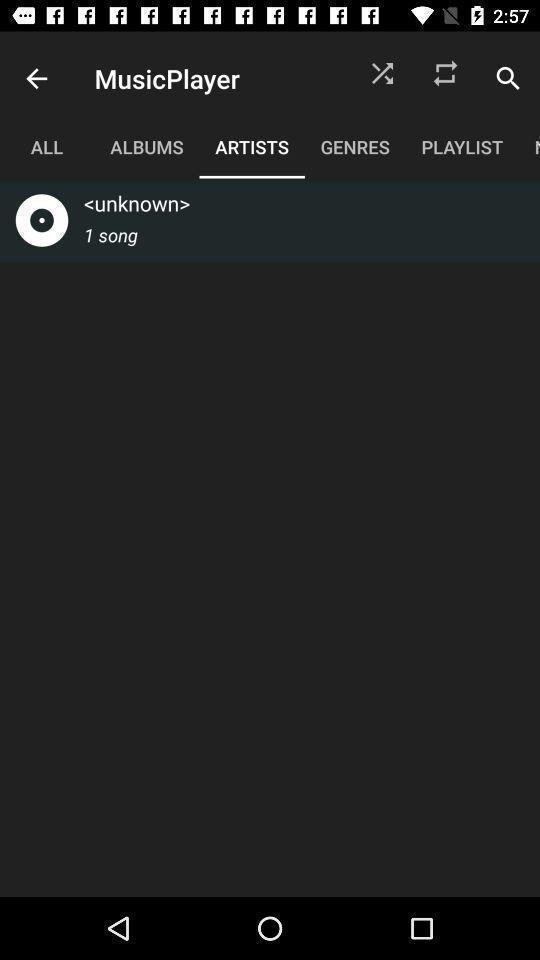Describe the key features of this screenshot. Screen displaying artists page in a music player app. 